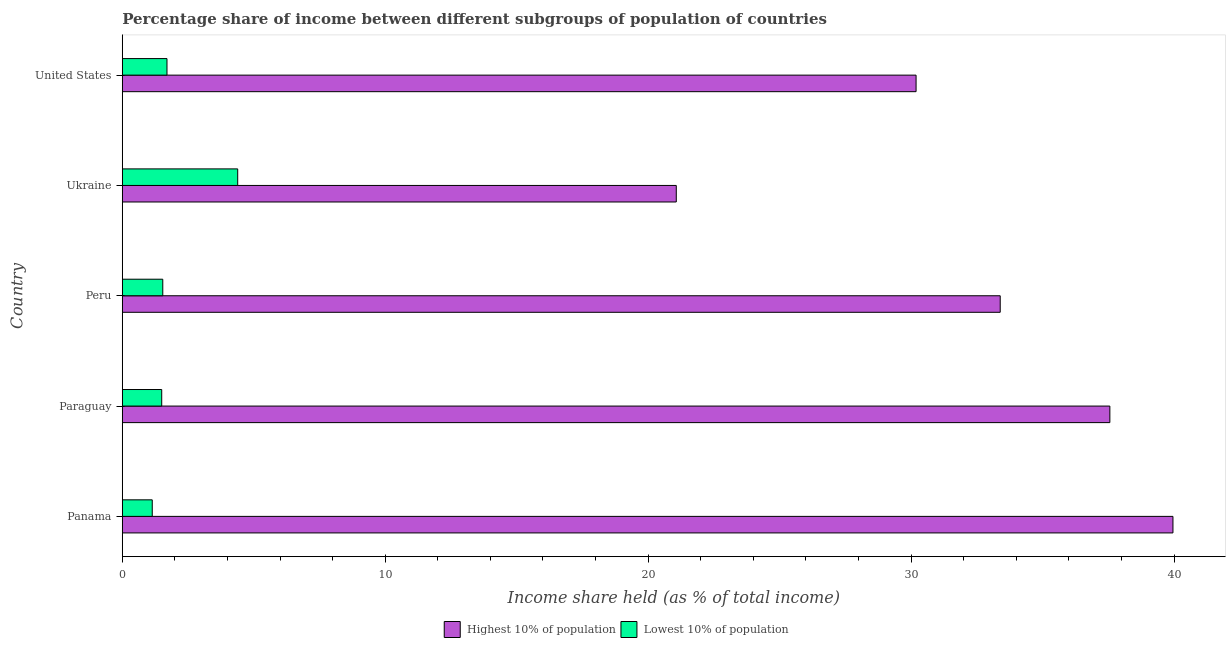How many different coloured bars are there?
Your response must be concise. 2. Are the number of bars on each tick of the Y-axis equal?
Provide a short and direct response. Yes. How many bars are there on the 1st tick from the bottom?
Your response must be concise. 2. What is the label of the 3rd group of bars from the top?
Offer a very short reply. Peru. In how many cases, is the number of bars for a given country not equal to the number of legend labels?
Provide a short and direct response. 0. What is the income share held by lowest 10% of the population in Panama?
Your response must be concise. 1.14. Across all countries, what is the maximum income share held by highest 10% of the population?
Your answer should be compact. 39.96. Across all countries, what is the minimum income share held by lowest 10% of the population?
Your response must be concise. 1.14. In which country was the income share held by lowest 10% of the population maximum?
Offer a terse response. Ukraine. In which country was the income share held by lowest 10% of the population minimum?
Provide a short and direct response. Panama. What is the total income share held by lowest 10% of the population in the graph?
Provide a short and direct response. 10.27. What is the difference between the income share held by lowest 10% of the population in Paraguay and that in Peru?
Ensure brevity in your answer.  -0.04. What is the difference between the income share held by highest 10% of the population in Panama and the income share held by lowest 10% of the population in United States?
Keep it short and to the point. 38.26. What is the average income share held by highest 10% of the population per country?
Your response must be concise. 32.43. What is the difference between the income share held by lowest 10% of the population and income share held by highest 10% of the population in Ukraine?
Offer a terse response. -16.68. In how many countries, is the income share held by lowest 10% of the population greater than 38 %?
Make the answer very short. 0. What is the ratio of the income share held by highest 10% of the population in Peru to that in Ukraine?
Ensure brevity in your answer.  1.58. Is the difference between the income share held by highest 10% of the population in Paraguay and Ukraine greater than the difference between the income share held by lowest 10% of the population in Paraguay and Ukraine?
Your answer should be very brief. Yes. What is the difference between the highest and the second highest income share held by lowest 10% of the population?
Your answer should be very brief. 2.69. What is the difference between the highest and the lowest income share held by highest 10% of the population?
Give a very brief answer. 18.89. In how many countries, is the income share held by highest 10% of the population greater than the average income share held by highest 10% of the population taken over all countries?
Make the answer very short. 3. What does the 2nd bar from the top in Ukraine represents?
Provide a succinct answer. Highest 10% of population. What does the 1st bar from the bottom in United States represents?
Keep it short and to the point. Highest 10% of population. How many bars are there?
Your response must be concise. 10. How many countries are there in the graph?
Keep it short and to the point. 5. What is the difference between two consecutive major ticks on the X-axis?
Provide a short and direct response. 10. Does the graph contain any zero values?
Your answer should be very brief. No. How many legend labels are there?
Keep it short and to the point. 2. How are the legend labels stacked?
Offer a very short reply. Horizontal. What is the title of the graph?
Offer a very short reply. Percentage share of income between different subgroups of population of countries. What is the label or title of the X-axis?
Offer a terse response. Income share held (as % of total income). What is the label or title of the Y-axis?
Your answer should be compact. Country. What is the Income share held (as % of total income) in Highest 10% of population in Panama?
Provide a short and direct response. 39.96. What is the Income share held (as % of total income) of Lowest 10% of population in Panama?
Make the answer very short. 1.14. What is the Income share held (as % of total income) of Highest 10% of population in Paraguay?
Your answer should be very brief. 37.56. What is the Income share held (as % of total income) of Highest 10% of population in Peru?
Make the answer very short. 33.39. What is the Income share held (as % of total income) in Lowest 10% of population in Peru?
Offer a very short reply. 1.54. What is the Income share held (as % of total income) in Highest 10% of population in Ukraine?
Your response must be concise. 21.07. What is the Income share held (as % of total income) of Lowest 10% of population in Ukraine?
Offer a very short reply. 4.39. What is the Income share held (as % of total income) of Highest 10% of population in United States?
Your answer should be very brief. 30.19. Across all countries, what is the maximum Income share held (as % of total income) of Highest 10% of population?
Your response must be concise. 39.96. Across all countries, what is the maximum Income share held (as % of total income) in Lowest 10% of population?
Your response must be concise. 4.39. Across all countries, what is the minimum Income share held (as % of total income) in Highest 10% of population?
Give a very brief answer. 21.07. Across all countries, what is the minimum Income share held (as % of total income) in Lowest 10% of population?
Provide a short and direct response. 1.14. What is the total Income share held (as % of total income) in Highest 10% of population in the graph?
Keep it short and to the point. 162.17. What is the total Income share held (as % of total income) in Lowest 10% of population in the graph?
Your answer should be very brief. 10.27. What is the difference between the Income share held (as % of total income) in Lowest 10% of population in Panama and that in Paraguay?
Offer a terse response. -0.36. What is the difference between the Income share held (as % of total income) of Highest 10% of population in Panama and that in Peru?
Your response must be concise. 6.57. What is the difference between the Income share held (as % of total income) in Highest 10% of population in Panama and that in Ukraine?
Your answer should be very brief. 18.89. What is the difference between the Income share held (as % of total income) in Lowest 10% of population in Panama and that in Ukraine?
Your answer should be compact. -3.25. What is the difference between the Income share held (as % of total income) of Highest 10% of population in Panama and that in United States?
Your answer should be very brief. 9.77. What is the difference between the Income share held (as % of total income) of Lowest 10% of population in Panama and that in United States?
Give a very brief answer. -0.56. What is the difference between the Income share held (as % of total income) of Highest 10% of population in Paraguay and that in Peru?
Offer a very short reply. 4.17. What is the difference between the Income share held (as % of total income) in Lowest 10% of population in Paraguay and that in Peru?
Provide a short and direct response. -0.04. What is the difference between the Income share held (as % of total income) of Highest 10% of population in Paraguay and that in Ukraine?
Provide a short and direct response. 16.49. What is the difference between the Income share held (as % of total income) in Lowest 10% of population in Paraguay and that in Ukraine?
Your answer should be very brief. -2.89. What is the difference between the Income share held (as % of total income) in Highest 10% of population in Paraguay and that in United States?
Make the answer very short. 7.37. What is the difference between the Income share held (as % of total income) in Lowest 10% of population in Paraguay and that in United States?
Your response must be concise. -0.2. What is the difference between the Income share held (as % of total income) in Highest 10% of population in Peru and that in Ukraine?
Offer a terse response. 12.32. What is the difference between the Income share held (as % of total income) in Lowest 10% of population in Peru and that in Ukraine?
Give a very brief answer. -2.85. What is the difference between the Income share held (as % of total income) of Highest 10% of population in Peru and that in United States?
Your response must be concise. 3.2. What is the difference between the Income share held (as % of total income) of Lowest 10% of population in Peru and that in United States?
Keep it short and to the point. -0.16. What is the difference between the Income share held (as % of total income) of Highest 10% of population in Ukraine and that in United States?
Your answer should be compact. -9.12. What is the difference between the Income share held (as % of total income) in Lowest 10% of population in Ukraine and that in United States?
Your answer should be very brief. 2.69. What is the difference between the Income share held (as % of total income) of Highest 10% of population in Panama and the Income share held (as % of total income) of Lowest 10% of population in Paraguay?
Keep it short and to the point. 38.46. What is the difference between the Income share held (as % of total income) in Highest 10% of population in Panama and the Income share held (as % of total income) in Lowest 10% of population in Peru?
Provide a short and direct response. 38.42. What is the difference between the Income share held (as % of total income) in Highest 10% of population in Panama and the Income share held (as % of total income) in Lowest 10% of population in Ukraine?
Give a very brief answer. 35.57. What is the difference between the Income share held (as % of total income) of Highest 10% of population in Panama and the Income share held (as % of total income) of Lowest 10% of population in United States?
Your response must be concise. 38.26. What is the difference between the Income share held (as % of total income) of Highest 10% of population in Paraguay and the Income share held (as % of total income) of Lowest 10% of population in Peru?
Offer a terse response. 36.02. What is the difference between the Income share held (as % of total income) in Highest 10% of population in Paraguay and the Income share held (as % of total income) in Lowest 10% of population in Ukraine?
Keep it short and to the point. 33.17. What is the difference between the Income share held (as % of total income) of Highest 10% of population in Paraguay and the Income share held (as % of total income) of Lowest 10% of population in United States?
Your answer should be very brief. 35.86. What is the difference between the Income share held (as % of total income) in Highest 10% of population in Peru and the Income share held (as % of total income) in Lowest 10% of population in United States?
Your answer should be very brief. 31.69. What is the difference between the Income share held (as % of total income) in Highest 10% of population in Ukraine and the Income share held (as % of total income) in Lowest 10% of population in United States?
Offer a terse response. 19.37. What is the average Income share held (as % of total income) of Highest 10% of population per country?
Your answer should be compact. 32.43. What is the average Income share held (as % of total income) of Lowest 10% of population per country?
Your answer should be compact. 2.05. What is the difference between the Income share held (as % of total income) of Highest 10% of population and Income share held (as % of total income) of Lowest 10% of population in Panama?
Give a very brief answer. 38.82. What is the difference between the Income share held (as % of total income) of Highest 10% of population and Income share held (as % of total income) of Lowest 10% of population in Paraguay?
Your response must be concise. 36.06. What is the difference between the Income share held (as % of total income) in Highest 10% of population and Income share held (as % of total income) in Lowest 10% of population in Peru?
Offer a terse response. 31.85. What is the difference between the Income share held (as % of total income) in Highest 10% of population and Income share held (as % of total income) in Lowest 10% of population in Ukraine?
Offer a terse response. 16.68. What is the difference between the Income share held (as % of total income) in Highest 10% of population and Income share held (as % of total income) in Lowest 10% of population in United States?
Offer a very short reply. 28.49. What is the ratio of the Income share held (as % of total income) of Highest 10% of population in Panama to that in Paraguay?
Offer a very short reply. 1.06. What is the ratio of the Income share held (as % of total income) in Lowest 10% of population in Panama to that in Paraguay?
Your answer should be compact. 0.76. What is the ratio of the Income share held (as % of total income) of Highest 10% of population in Panama to that in Peru?
Make the answer very short. 1.2. What is the ratio of the Income share held (as % of total income) of Lowest 10% of population in Panama to that in Peru?
Offer a terse response. 0.74. What is the ratio of the Income share held (as % of total income) of Highest 10% of population in Panama to that in Ukraine?
Provide a short and direct response. 1.9. What is the ratio of the Income share held (as % of total income) in Lowest 10% of population in Panama to that in Ukraine?
Your answer should be compact. 0.26. What is the ratio of the Income share held (as % of total income) in Highest 10% of population in Panama to that in United States?
Your answer should be compact. 1.32. What is the ratio of the Income share held (as % of total income) of Lowest 10% of population in Panama to that in United States?
Your response must be concise. 0.67. What is the ratio of the Income share held (as % of total income) of Highest 10% of population in Paraguay to that in Peru?
Make the answer very short. 1.12. What is the ratio of the Income share held (as % of total income) of Lowest 10% of population in Paraguay to that in Peru?
Provide a succinct answer. 0.97. What is the ratio of the Income share held (as % of total income) in Highest 10% of population in Paraguay to that in Ukraine?
Your response must be concise. 1.78. What is the ratio of the Income share held (as % of total income) of Lowest 10% of population in Paraguay to that in Ukraine?
Your response must be concise. 0.34. What is the ratio of the Income share held (as % of total income) of Highest 10% of population in Paraguay to that in United States?
Provide a succinct answer. 1.24. What is the ratio of the Income share held (as % of total income) of Lowest 10% of population in Paraguay to that in United States?
Offer a very short reply. 0.88. What is the ratio of the Income share held (as % of total income) in Highest 10% of population in Peru to that in Ukraine?
Provide a short and direct response. 1.58. What is the ratio of the Income share held (as % of total income) in Lowest 10% of population in Peru to that in Ukraine?
Make the answer very short. 0.35. What is the ratio of the Income share held (as % of total income) in Highest 10% of population in Peru to that in United States?
Offer a very short reply. 1.11. What is the ratio of the Income share held (as % of total income) in Lowest 10% of population in Peru to that in United States?
Offer a very short reply. 0.91. What is the ratio of the Income share held (as % of total income) in Highest 10% of population in Ukraine to that in United States?
Offer a very short reply. 0.7. What is the ratio of the Income share held (as % of total income) of Lowest 10% of population in Ukraine to that in United States?
Provide a short and direct response. 2.58. What is the difference between the highest and the second highest Income share held (as % of total income) of Lowest 10% of population?
Make the answer very short. 2.69. What is the difference between the highest and the lowest Income share held (as % of total income) in Highest 10% of population?
Your answer should be compact. 18.89. What is the difference between the highest and the lowest Income share held (as % of total income) of Lowest 10% of population?
Your answer should be compact. 3.25. 